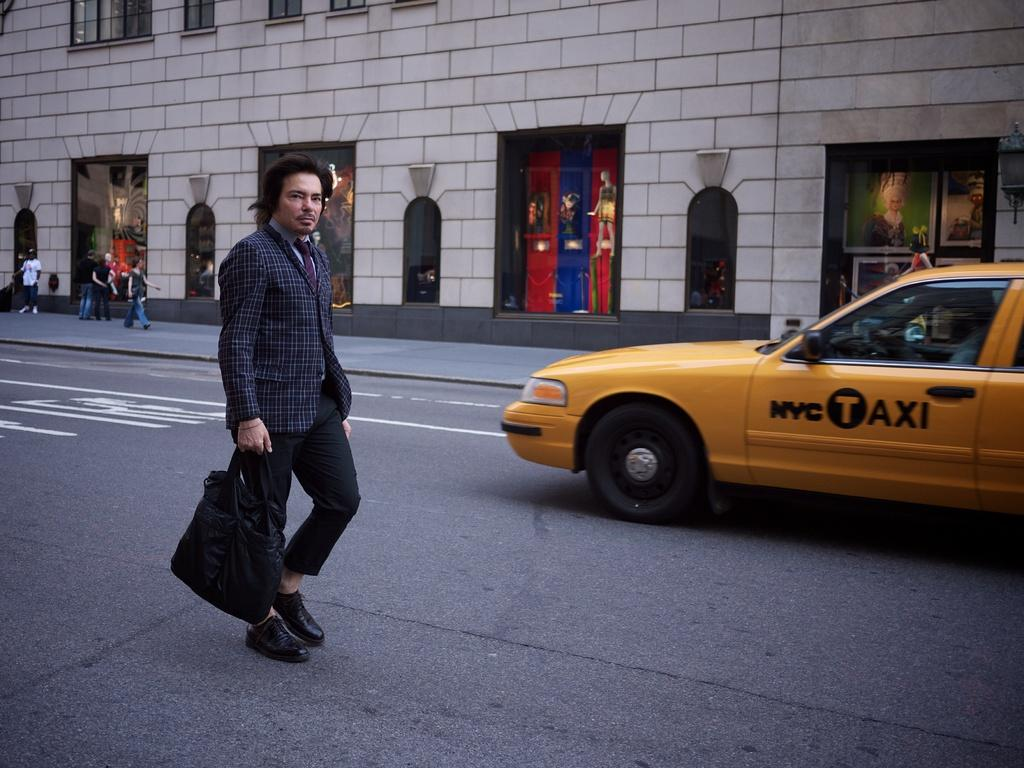<image>
Give a short and clear explanation of the subsequent image. man holding bag in street next to a nyc taxi 